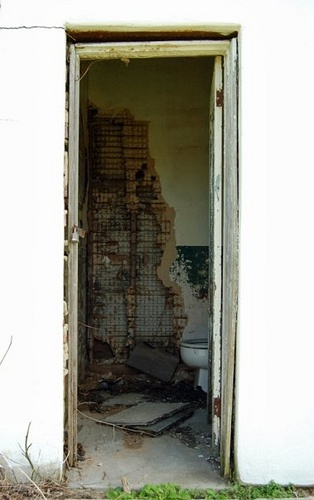Describe the objects in this image and their specific colors. I can see a toilet in white, gray, and black tones in this image. 